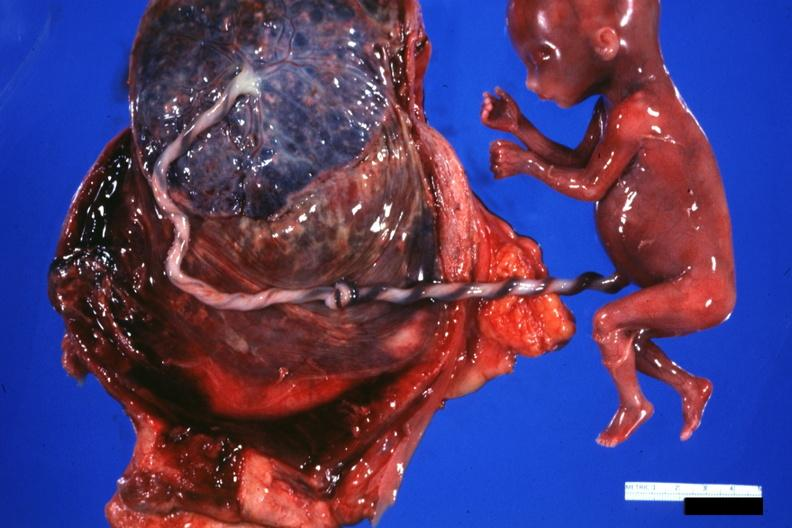s umbilical cord present?
Answer the question using a single word or phrase. Yes 